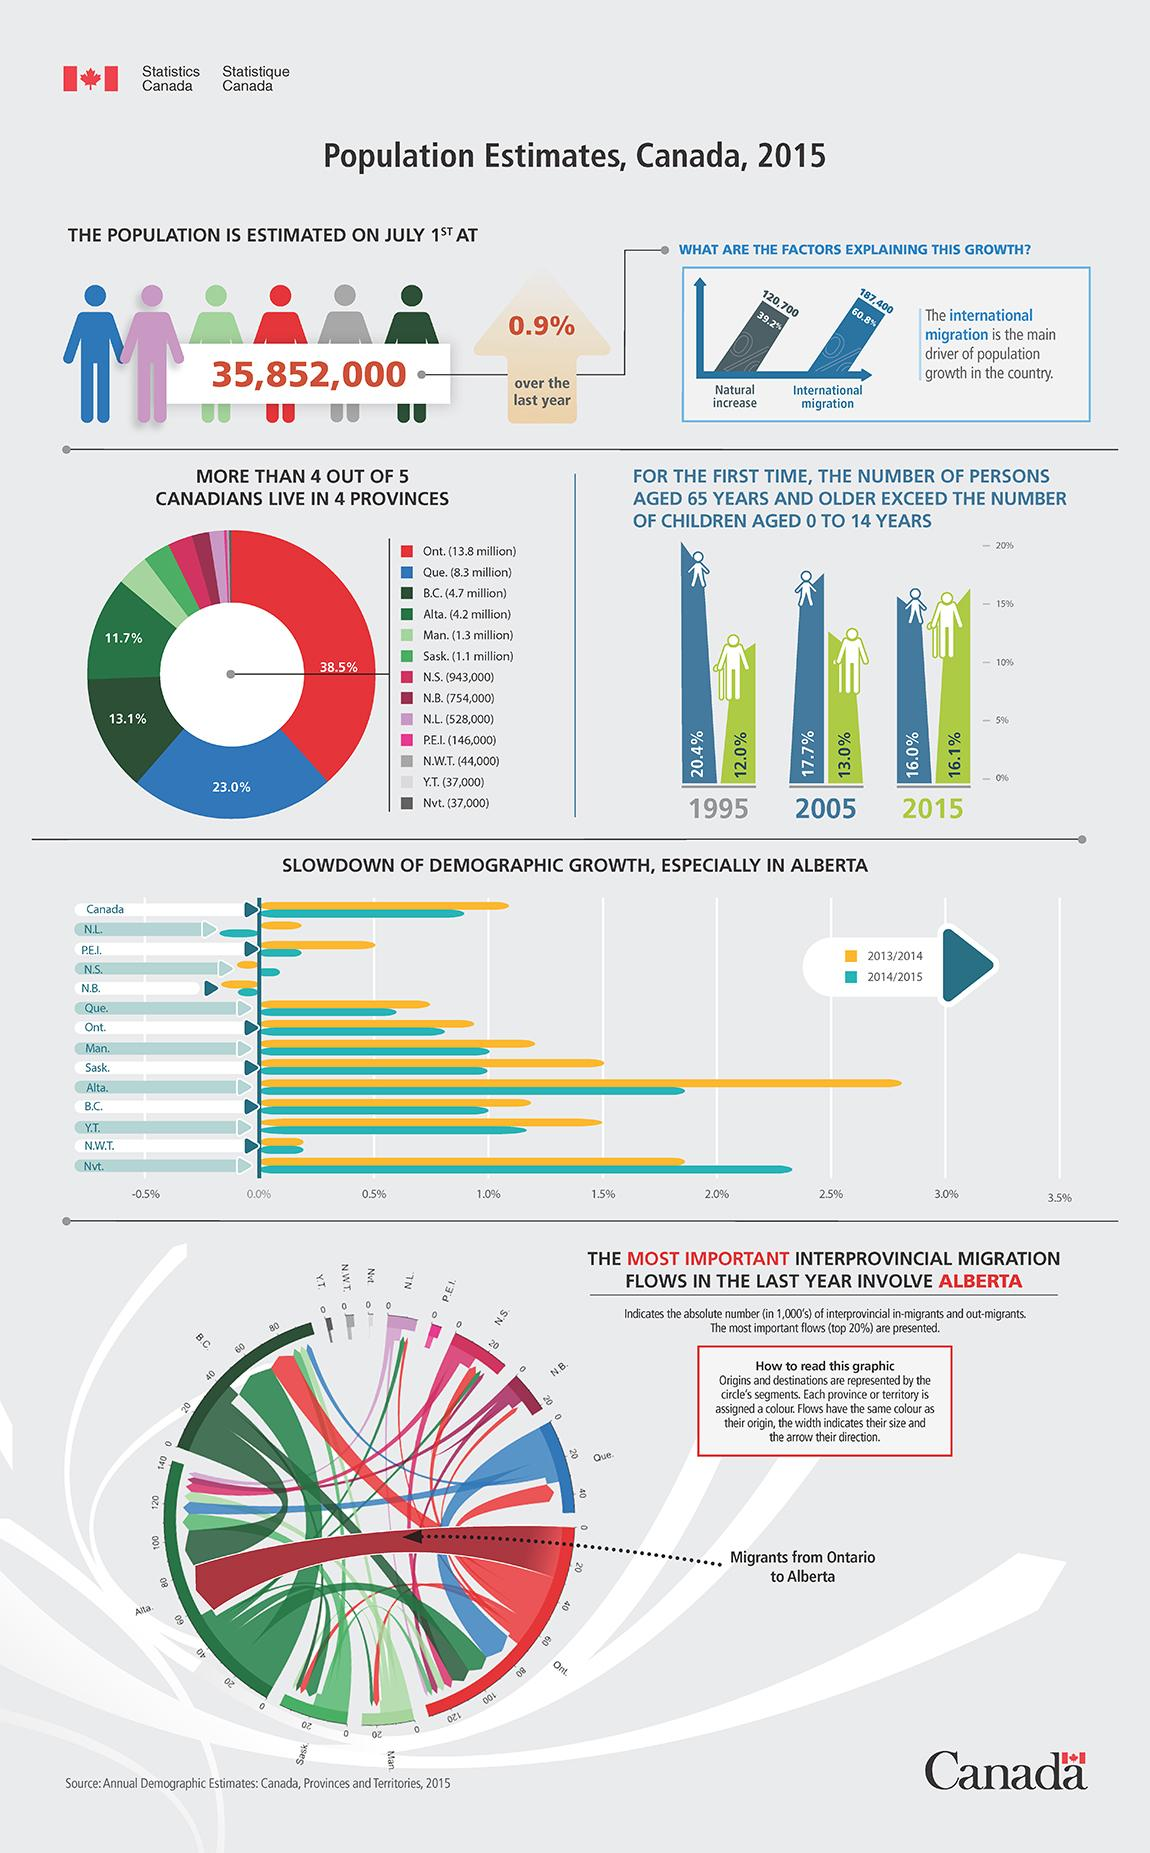Indicate a few pertinent items in this graphic. In 2005, the population of children aged 0-14 was 17.7%. In 2015, it is estimated that the population of Canada was approximately 35,852,000. In the graph, it can be observed that in 2015, the number of senior citizens exceeded the number of children below the age of 14. The total population has increased by 0.9% compared to the previous year. The population in the blue-colored province in the donut chart is approximately 8.3 million. 